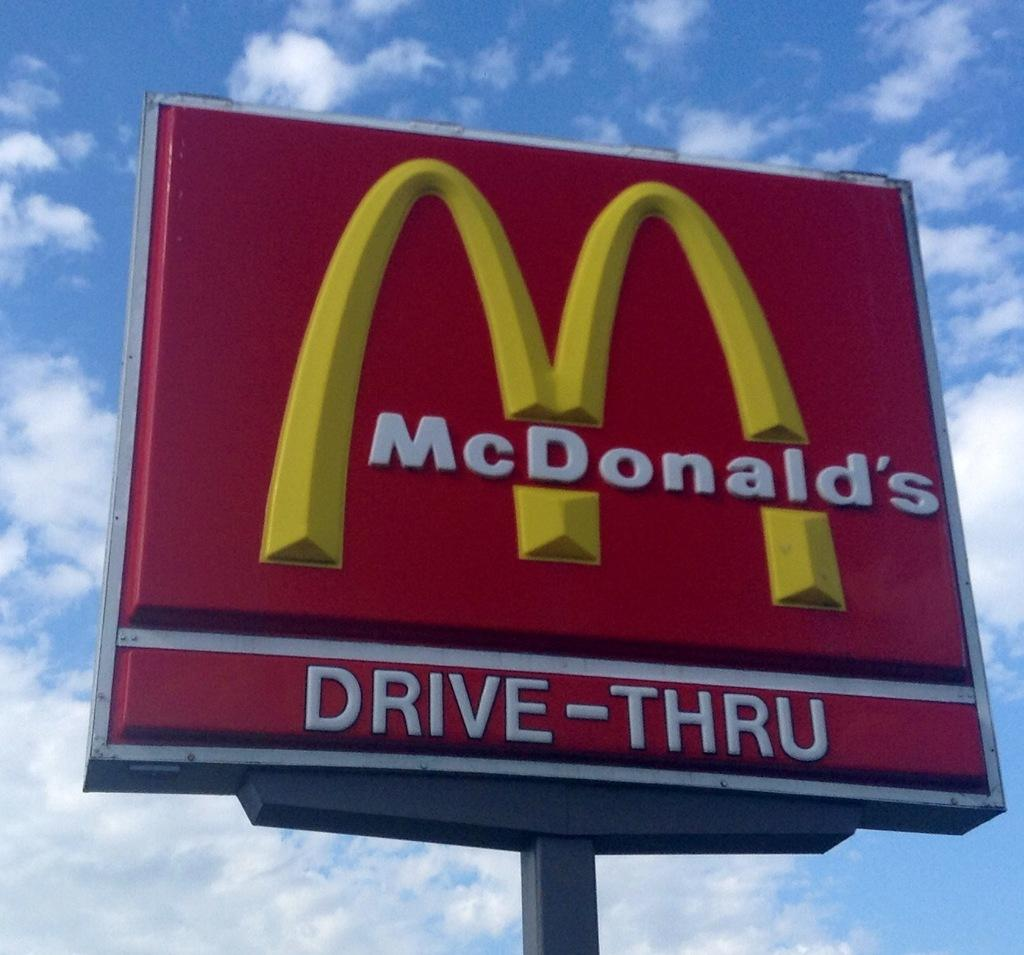<image>
Give a short and clear explanation of the subsequent image. A red, white and yellow drive thru McDonald's sign. 